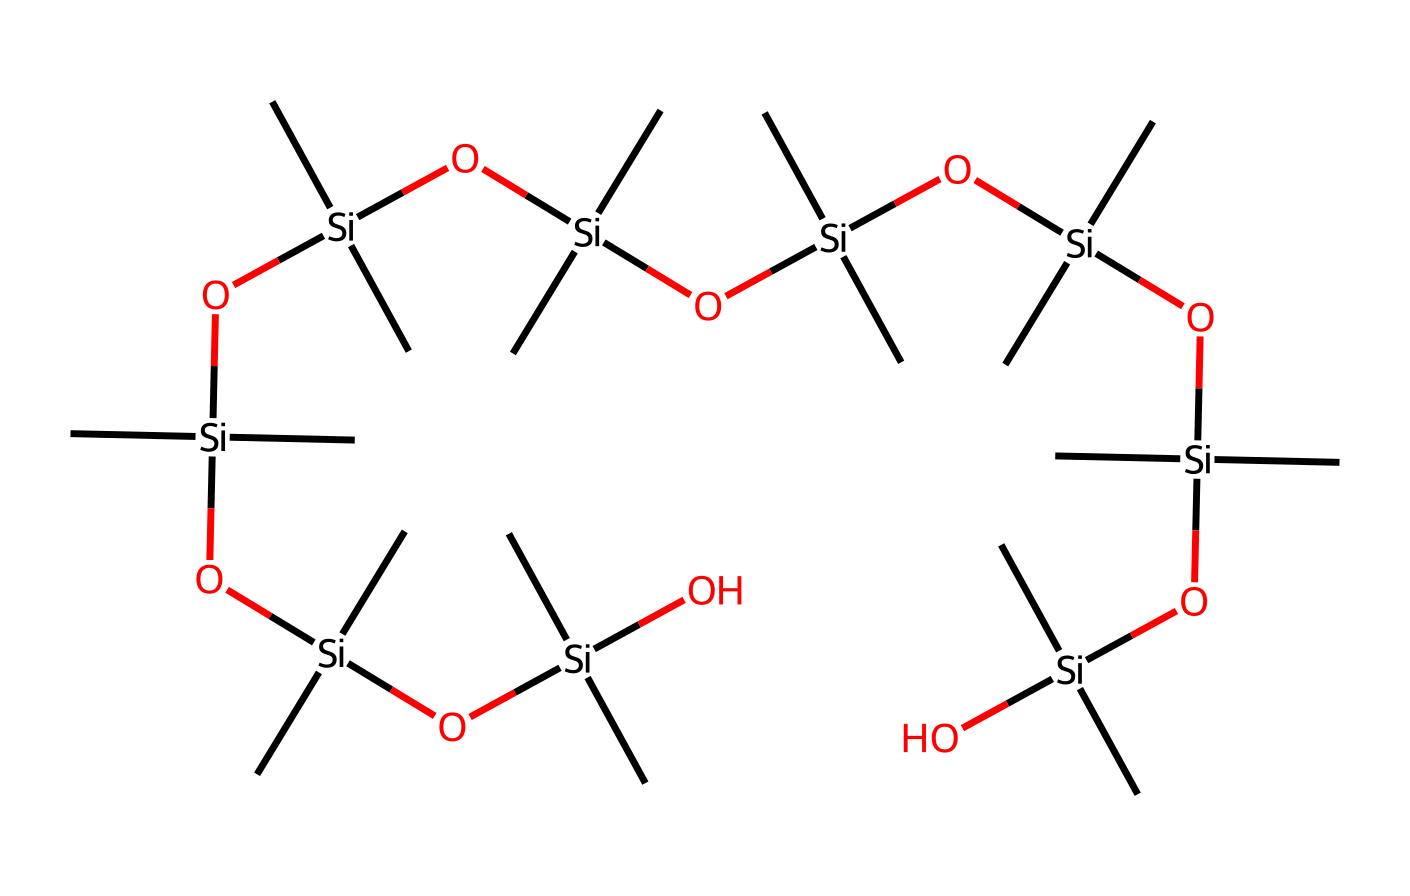What is the primary element in this chemical structure? The chemical structure contains silicon atoms (represented by Si) which are central to organosilicon compounds. Identifying the central atoms shows that silicon is the predominant element throughout the structure.
Answer: silicon How many oxygen atoms are present in the structure? By analyzing the SMILES representation, you can count the number of occurrences of the letter 'O', which corresponds to oxygen atoms. There are a total of 8 oxygen atoms in the structure based on the visual clues provided in the SMILES.
Answer: 8 What type of bonding is predominant in this chemical structure? The presence of multiple Si-O (silicon-oxygen) linkages in the structure indicates that the predominant bonding is covalent, characteristic of organosilicon compounds.
Answer: covalent What is the overall molecular formula of this compound? By interpreting the SMILES format, you can deduce that the formula can be derived from the counts of silicon, oxygen, and carbon atoms. The structure shows 8 Si, 8 O, and the total count of carbon atoms also aligns with the multiple alkyl groups, leading to the formula C32H70O8Si8.
Answer: C32H70O8Si8 What effect does the abundance of Si-O bonds have on the properties of this compound? The abundance of Si-O bonds enhances the hydrophobic properties of the compound, making it suitable for waterproofing applications. Analyzing the structure indicates that it is designed to repel water effectively.
Answer: hydrophobic How many alkyl (C) groups are present in the structure? The structure features multiple branches of alkyl groups, denoted by 'C' in the SMILES. By assessing the structure closely, you can conclude there are a total of 16 alkyl groups connected to the silicon atoms.
Answer: 16 What is the significance of the repeating units in this chemical? The repeating units indicate the compound's polymeric nature, which contributes to its durability and flexibility, essential traits for applications in skydiving equipment. Evaluating the pattern reveals that it forms a long-chain structure pivotal for performance in demanding environments.
Answer: polymeric nature 